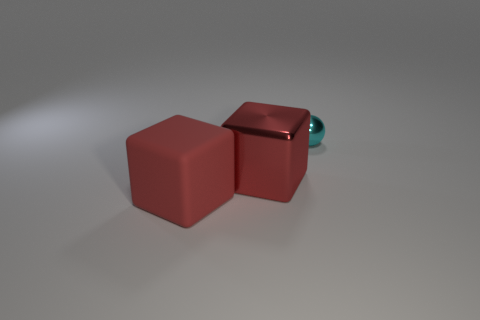Add 1 tiny cubes. How many objects exist? 4 Subtract all balls. How many objects are left? 2 Subtract 0 yellow cubes. How many objects are left? 3 Subtract all large cubes. Subtract all big shiny objects. How many objects are left? 0 Add 3 small cyan balls. How many small cyan balls are left? 4 Add 2 small metal spheres. How many small metal spheres exist? 3 